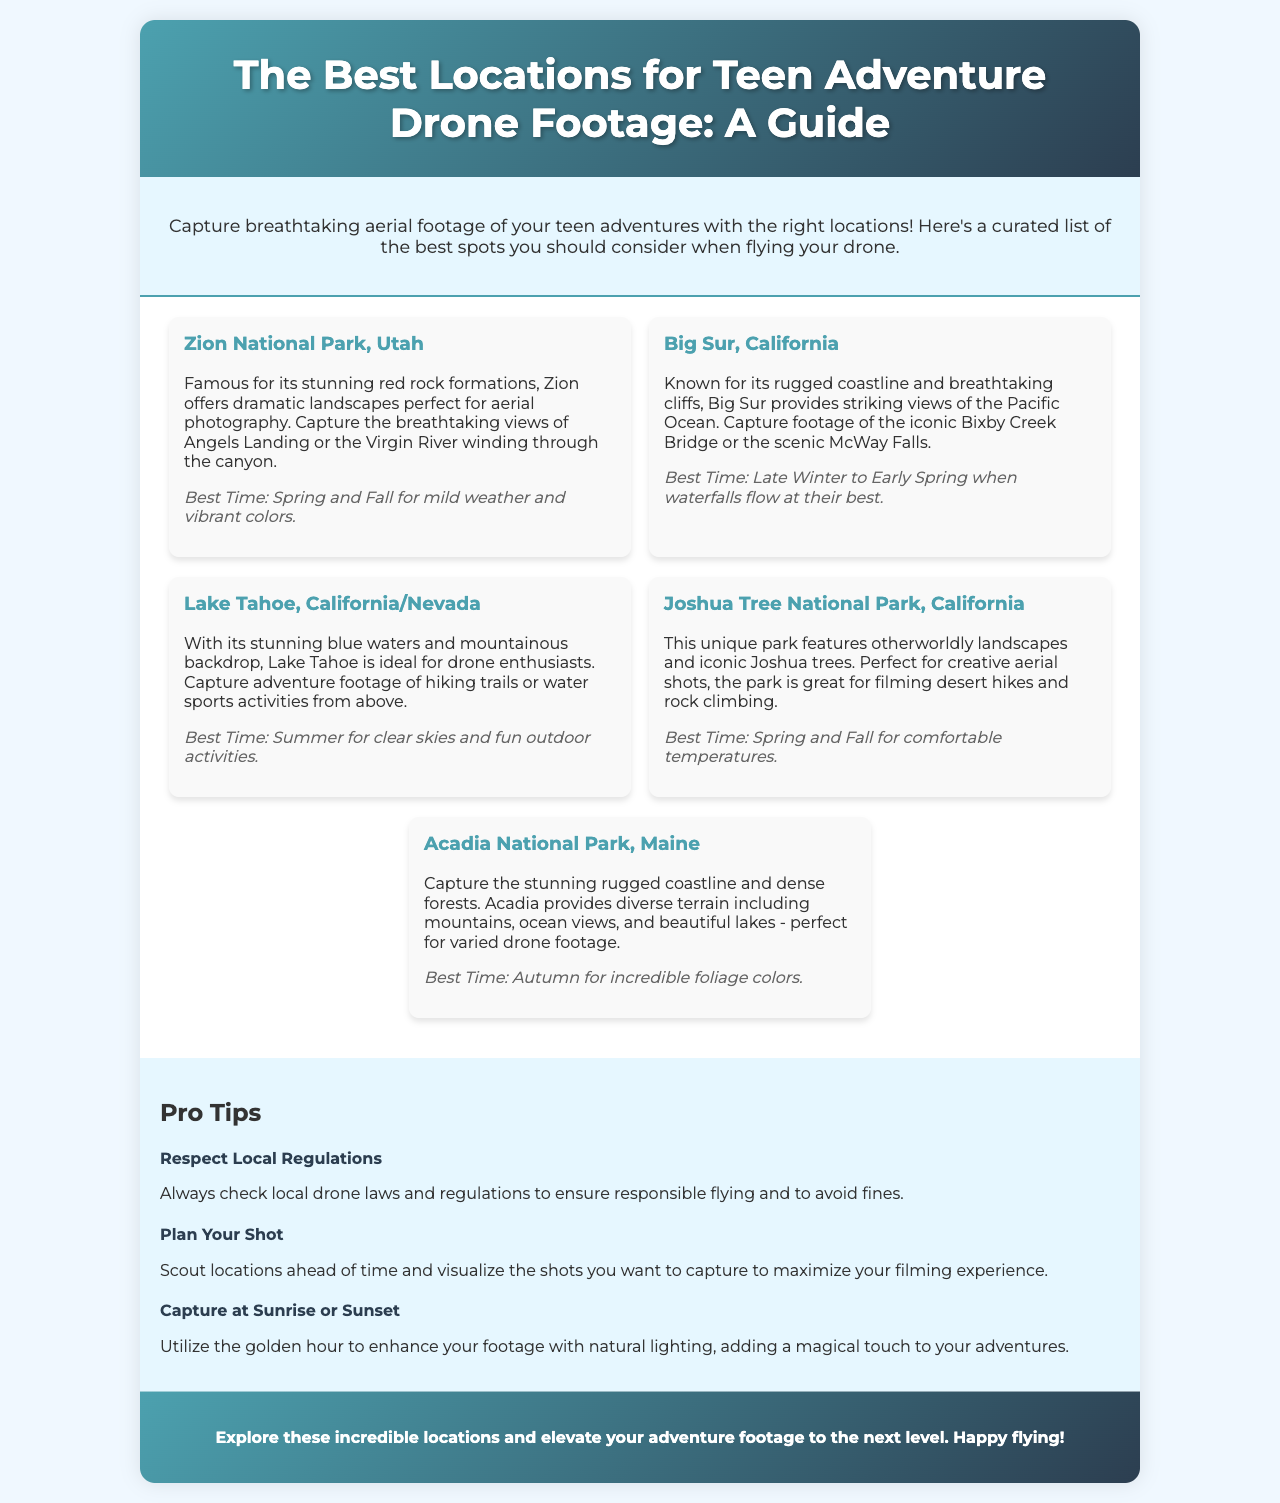What is the first location mentioned in the guide? The first location listed in the document is Zion National Park, Utah, which is described as famous for its stunning red rock formations.
Answer: Zion National Park, Utah What is the best time to visit Big Sur? According to the document, the best time to visit Big Sur is late winter to early spring when waterfalls flow at their best.
Answer: Late Winter to Early Spring Which park features iconic Joshua trees? The document specifically mentions Joshua Tree National Park as the one featuring iconic Joshua trees.
Answer: Joshua Tree National Park What type of footage can be captured at Lake Tahoe? The guide suggests capturing adventure footage of hiking trails or water sports activities from above at Lake Tahoe.
Answer: Hiking trails or water sports activities What is a key pro tip given in the document? A key pro tip provided is to respect local regulations, ensuring responsible flying and avoiding fines.
Answer: Respect Local Regulations Why is autumn recommended for visiting Acadia National Park? The document recommends autumn for visiting Acadia National Park due to the incredible foliage colors that can be captured.
Answer: Incredible foliage colors Which two seasons are suggested for visiting Joshua Tree National Park? The guide suggests visiting Joshua Tree National Park in spring and fall for comfortable temperatures.
Answer: Spring and Fall What lighting time is recommended for enhancing footage? The document mentions utilizing the golden hour at sunrise or sunset to enhance aerial footage with natural lighting.
Answer: Sunrise or Sunset 